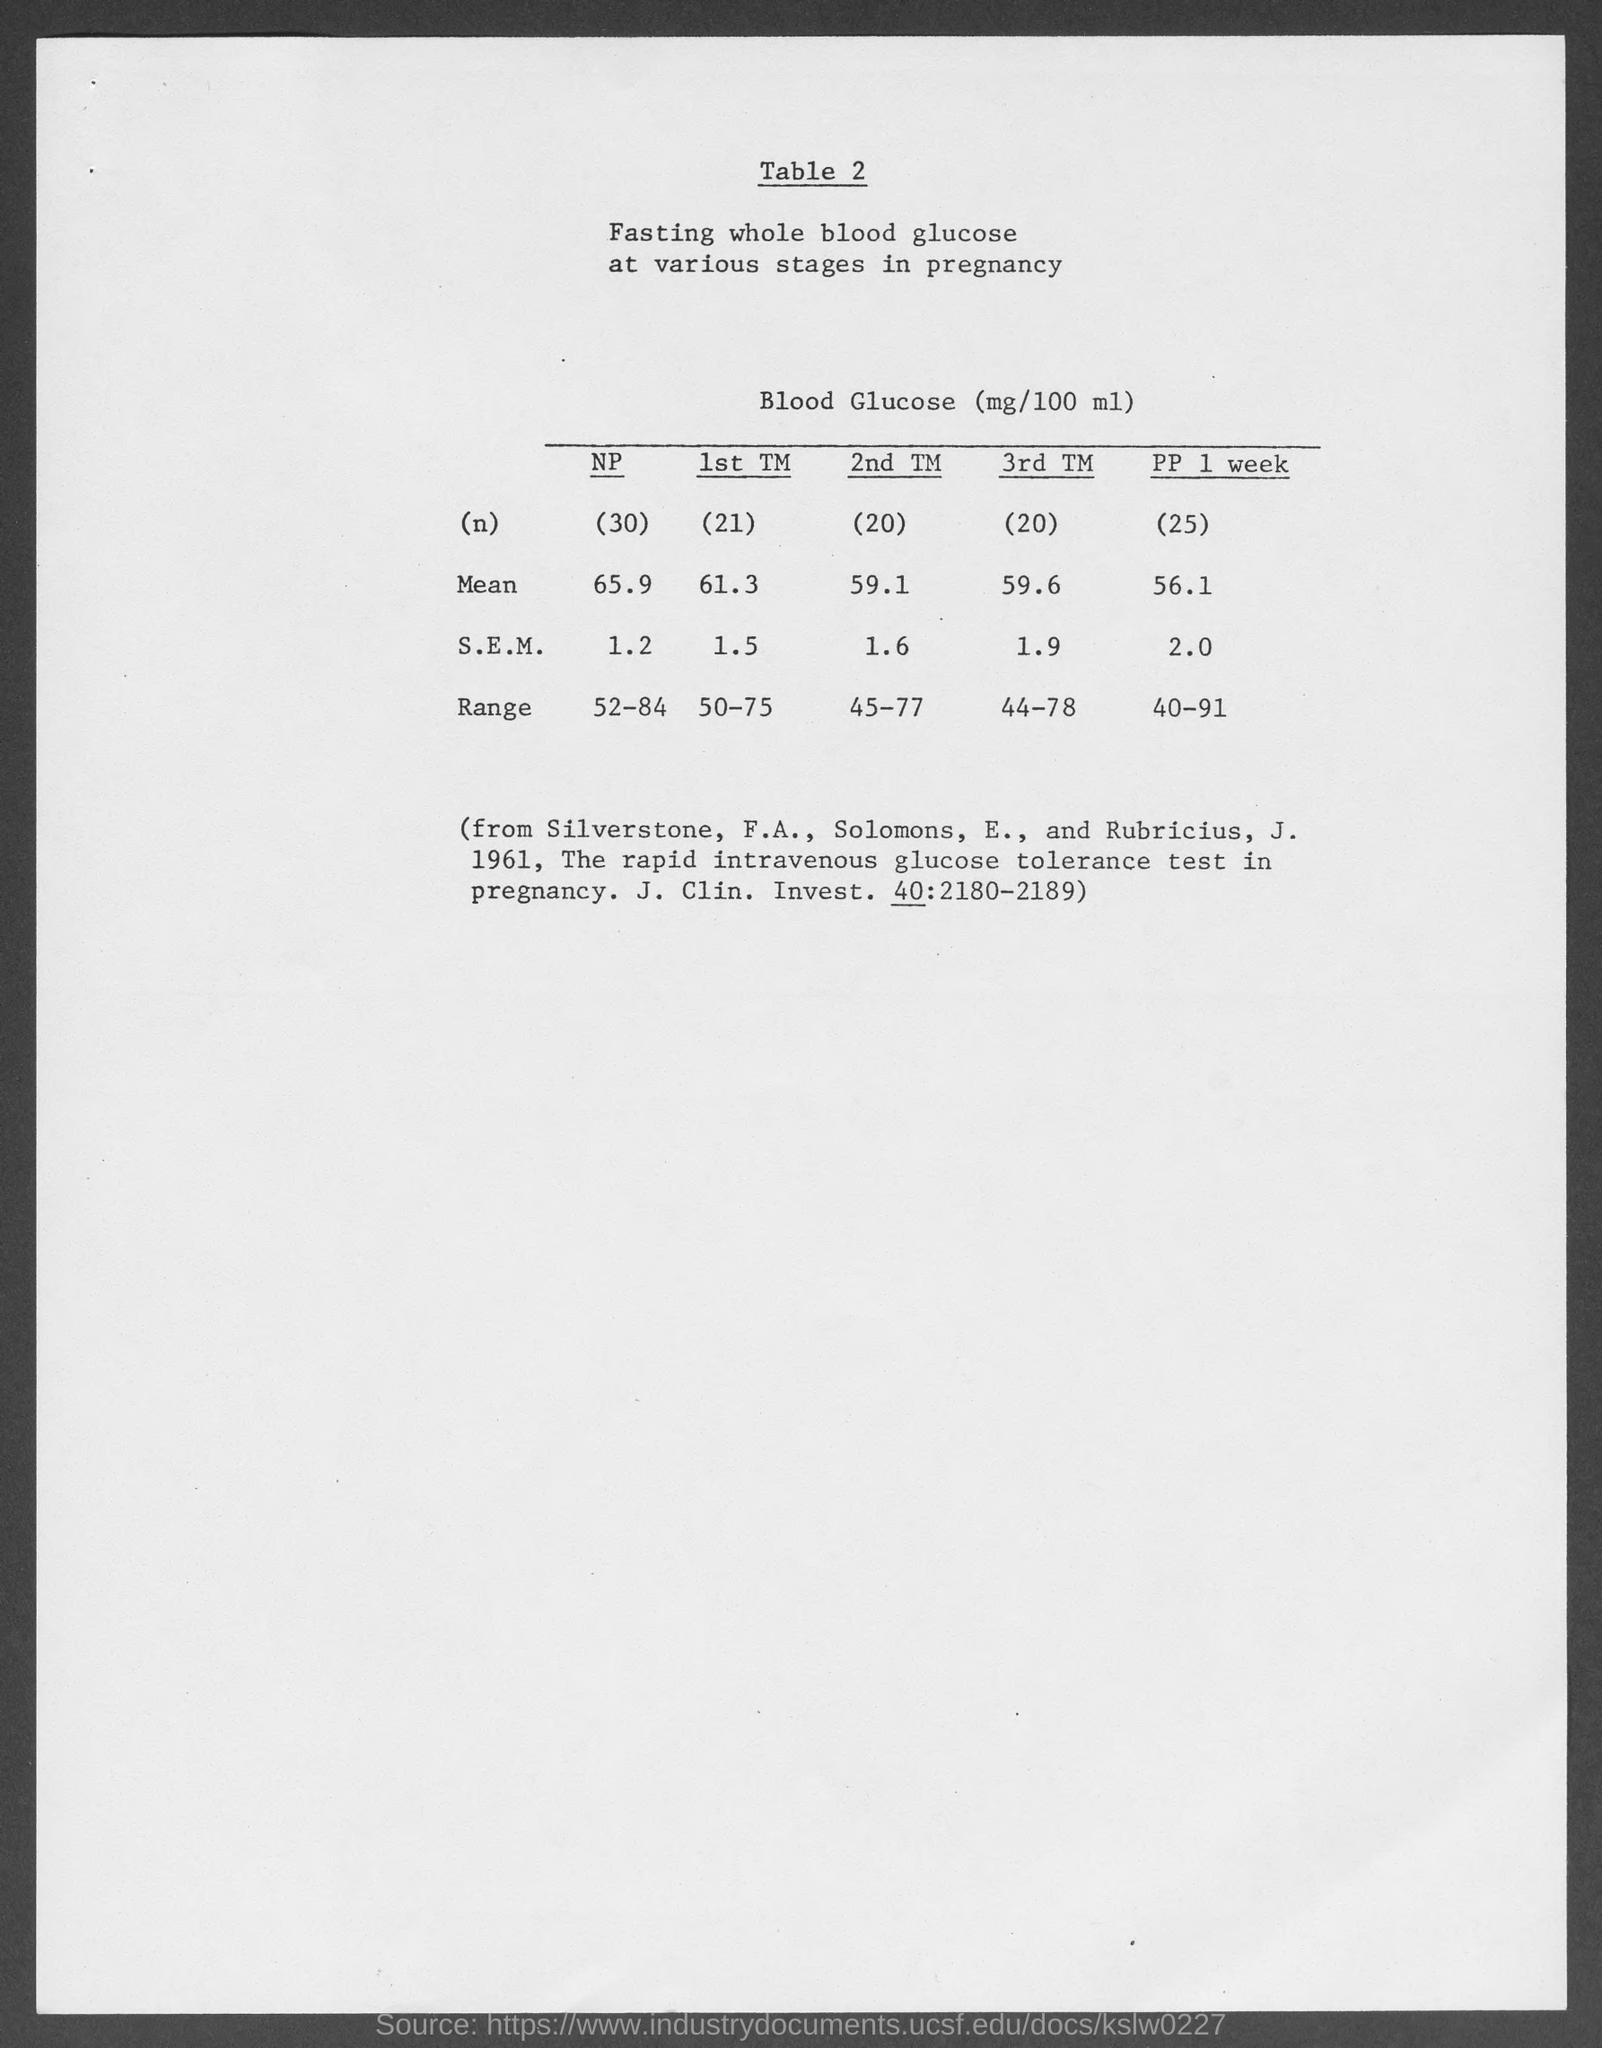What is the range of glucose levels during the third trimester? During the third trimester (3rd TM), the range of fasting blood glucose levels is from 44 to 78 mg/100 ml as shown in the table. 